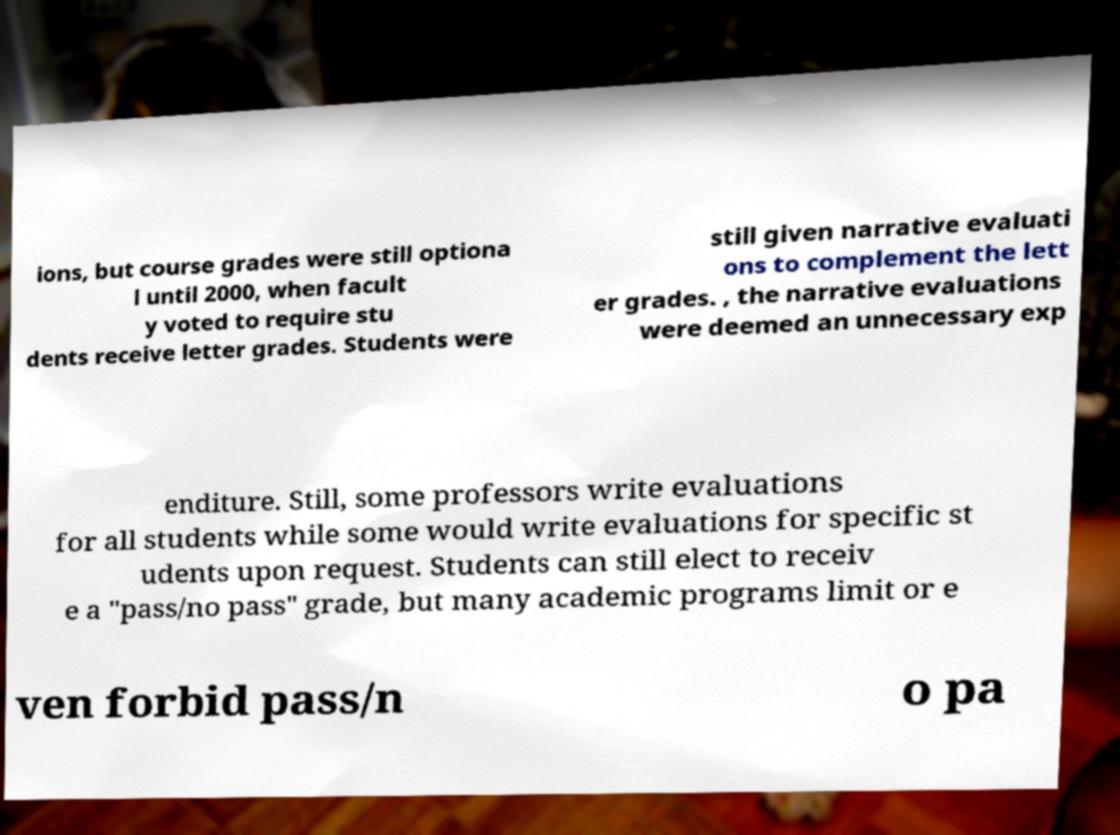Could you assist in decoding the text presented in this image and type it out clearly? ions, but course grades were still optiona l until 2000, when facult y voted to require stu dents receive letter grades. Students were still given narrative evaluati ons to complement the lett er grades. , the narrative evaluations were deemed an unnecessary exp enditure. Still, some professors write evaluations for all students while some would write evaluations for specific st udents upon request. Students can still elect to receiv e a "pass/no pass" grade, but many academic programs limit or e ven forbid pass/n o pa 